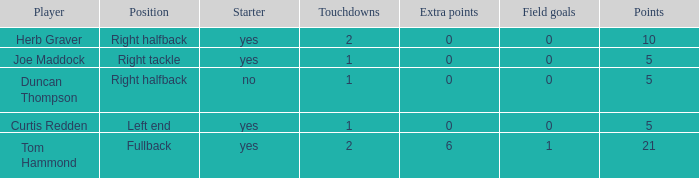Name the fewest touchdowns 1.0. 